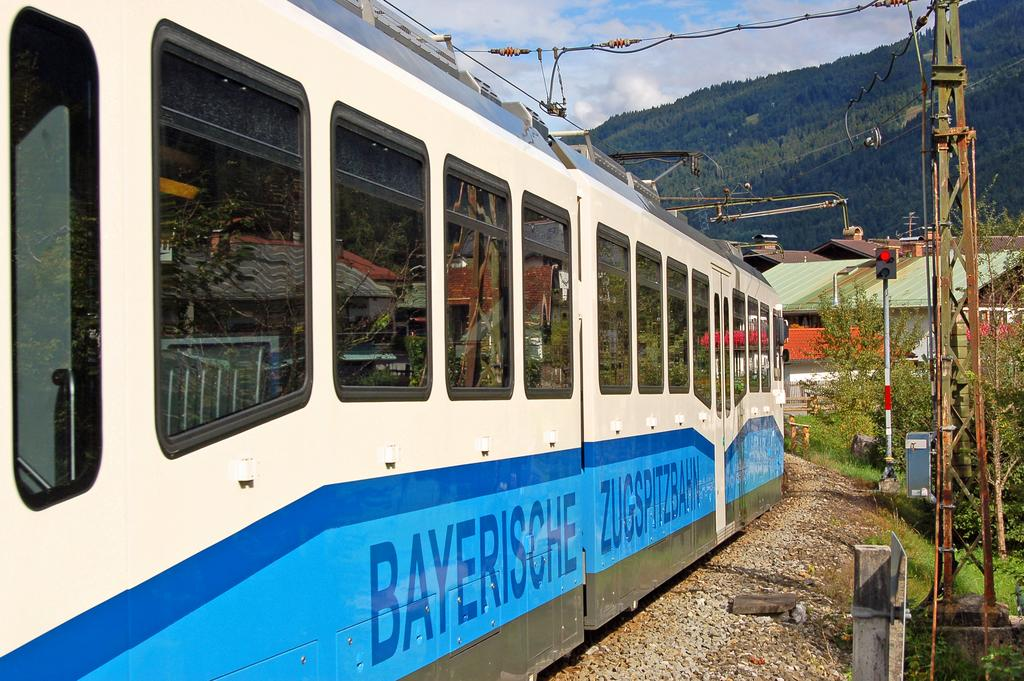<image>
Offer a succinct explanation of the picture presented. the word bayersche on the side of a train 